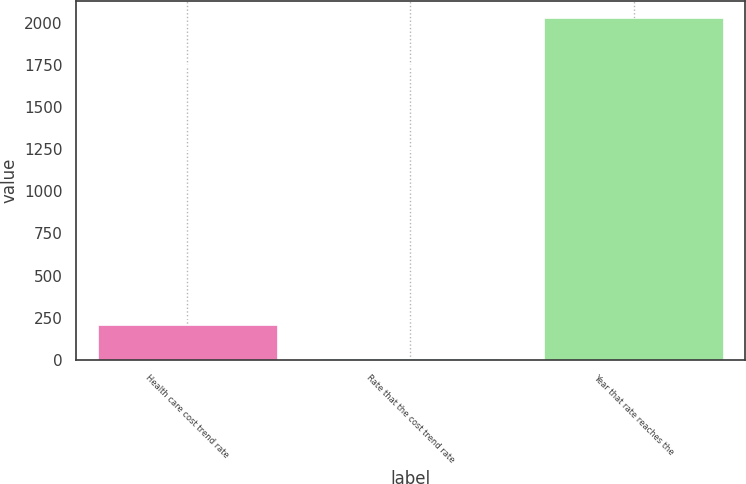Convert chart. <chart><loc_0><loc_0><loc_500><loc_500><bar_chart><fcel>Health care cost trend rate<fcel>Rate that the cost trend rate<fcel>Year that rate reaches the<nl><fcel>207.2<fcel>5<fcel>2027<nl></chart> 